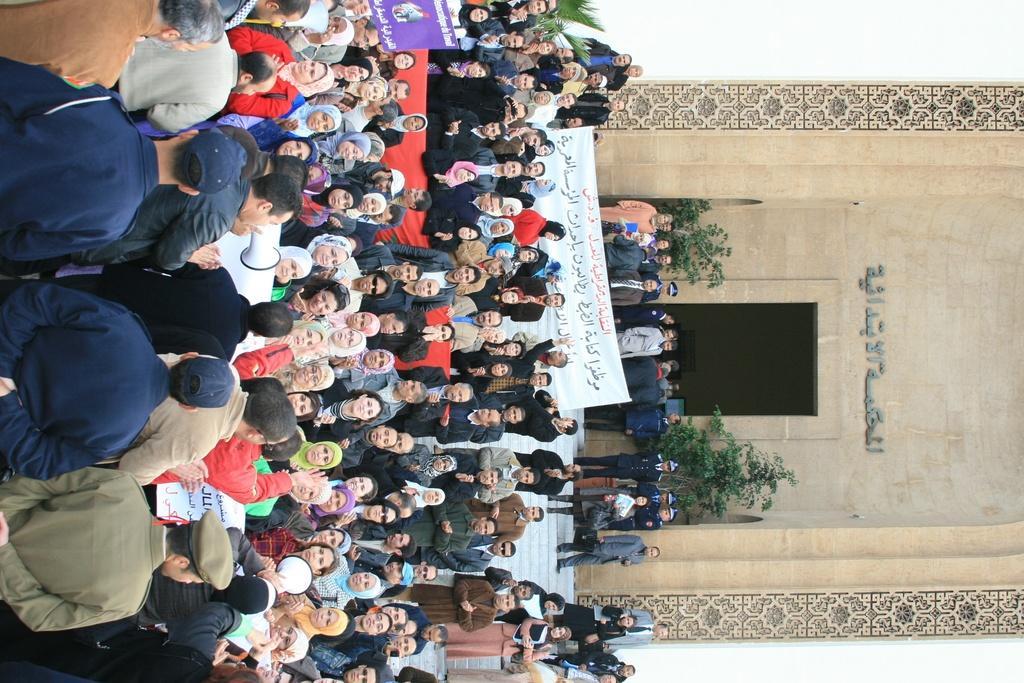Please provide a concise description of this image. There are groups of people standing. This is a banner. I think this is a placard. I can see a person holding a megaphone. These are the stairs. This is a building. I can see the trees. This looks like a name board. 